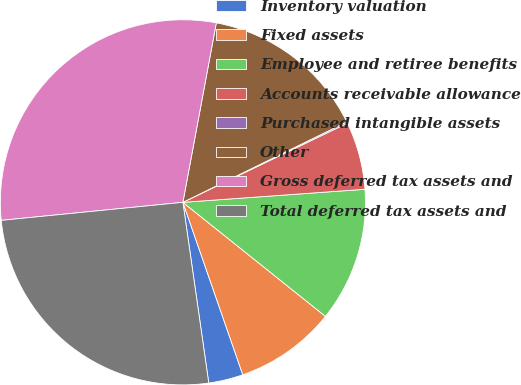Convert chart. <chart><loc_0><loc_0><loc_500><loc_500><pie_chart><fcel>Inventory valuation<fcel>Fixed assets<fcel>Employee and retiree benefits<fcel>Accounts receivable allowance<fcel>Purchased intangible assets<fcel>Other<fcel>Gross deferred tax assets and<fcel>Total deferred tax assets and<nl><fcel>3.06%<fcel>8.94%<fcel>11.88%<fcel>6.0%<fcel>0.12%<fcel>14.81%<fcel>29.51%<fcel>25.69%<nl></chart> 